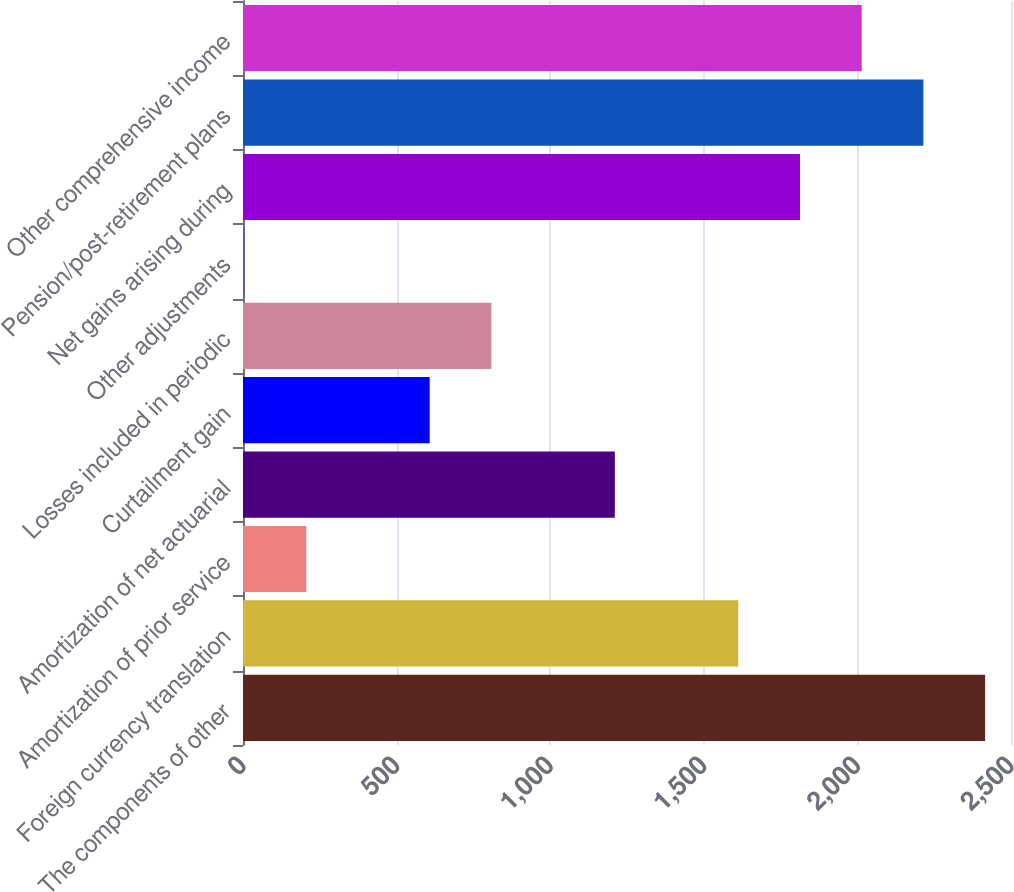Convert chart to OTSL. <chart><loc_0><loc_0><loc_500><loc_500><bar_chart><fcel>The components of other<fcel>Foreign currency translation<fcel>Amortization of prior service<fcel>Amortization of net actuarial<fcel>Curtailment gain<fcel>Losses included in periodic<fcel>Other adjustments<fcel>Net gains arising during<fcel>Pension/post-retirement plans<fcel>Other comprehensive income<nl><fcel>2415.8<fcel>1612.2<fcel>205.9<fcel>1210.4<fcel>607.7<fcel>808.6<fcel>5<fcel>1813.1<fcel>2214.9<fcel>2014<nl></chart> 